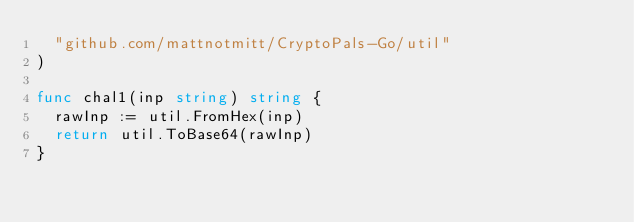<code> <loc_0><loc_0><loc_500><loc_500><_Go_>	"github.com/mattnotmitt/CryptoPals-Go/util"
)

func chal1(inp string) string {
	rawInp := util.FromHex(inp)
	return util.ToBase64(rawInp)
}
</code> 